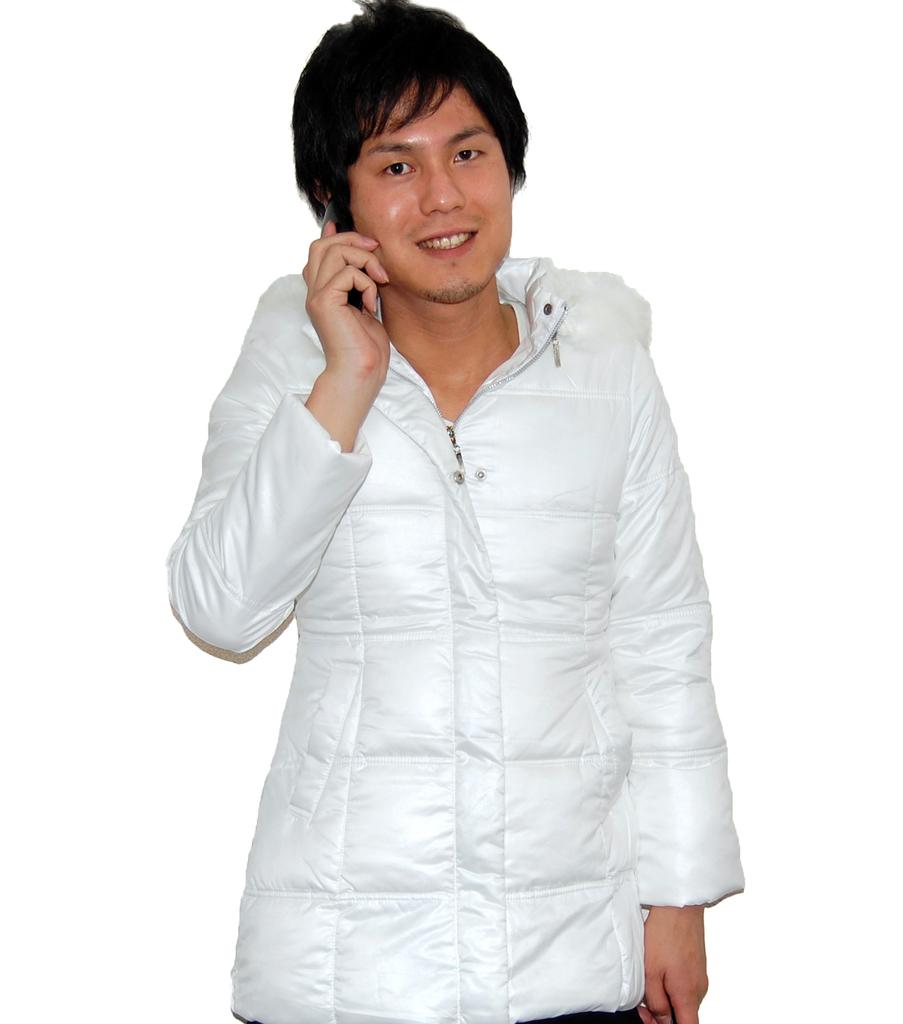What is the main subject of the image? The main subject of the image is a man. What is the man doing in the image? The man is standing in the image. What is the man's facial expression in the image? The man is smiling in the image. What is the man holding in his hand in the image? The man is holding an object in his hand in the image. What color are the clothes the man is wearing in the image? The man is wearing white clothes in the image. What type of pear is the man eating in the image? There is no pear present in the image, and the man is not eating anything. 